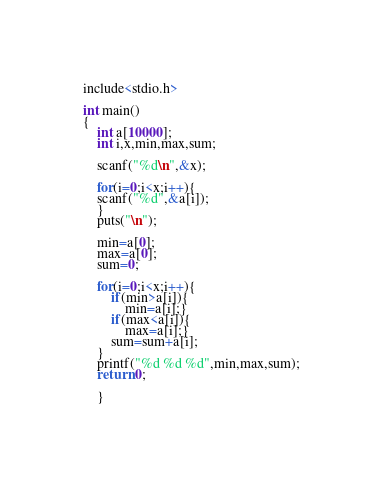<code> <loc_0><loc_0><loc_500><loc_500><_C_>include<stdio.h>

int main()
{
	int a[10000];
	int i,x,min,max,sum;
	
	scanf("%d\n",&x);
	
	for(i=0;i<x;i++){
	scanf("%d",&a[i]);
	}
	puts("\n");
	
	min=a[0];
	max=a[0];
	sum=0;
	
	for(i=0;i<x;i++){
		if(min>a[i]){
			min=a[i];}
		if(max<a[i]){
			max=a[i];}
		sum=sum+a[i];
	}
	printf("%d %d %d",min,max,sum);
	return 0;
	
	}</code> 